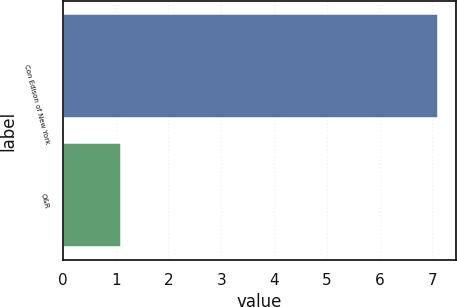<chart> <loc_0><loc_0><loc_500><loc_500><bar_chart><fcel>Con Edison of New York<fcel>O&R<nl><fcel>7.1<fcel>1.1<nl></chart> 